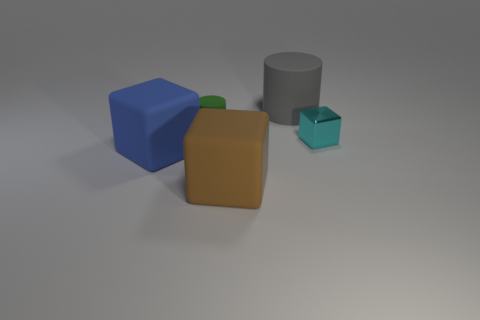Add 2 small metallic blocks. How many objects exist? 7 Subtract 1 blocks. How many blocks are left? 2 Subtract all matte blocks. How many blocks are left? 1 Subtract all cylinders. How many objects are left? 3 Add 3 small cyan things. How many small cyan things exist? 4 Subtract 1 cyan blocks. How many objects are left? 4 Subtract all gray cylinders. Subtract all big blue rubber spheres. How many objects are left? 4 Add 1 large rubber cylinders. How many large rubber cylinders are left? 2 